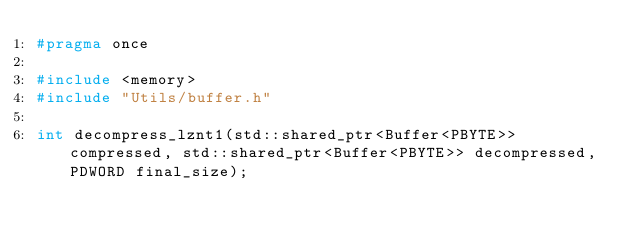Convert code to text. <code><loc_0><loc_0><loc_500><loc_500><_C_>#pragma once

#include <memory>
#include "Utils/buffer.h"

int decompress_lznt1(std::shared_ptr<Buffer<PBYTE>> compressed, std::shared_ptr<Buffer<PBYTE>> decompressed, PDWORD final_size);</code> 